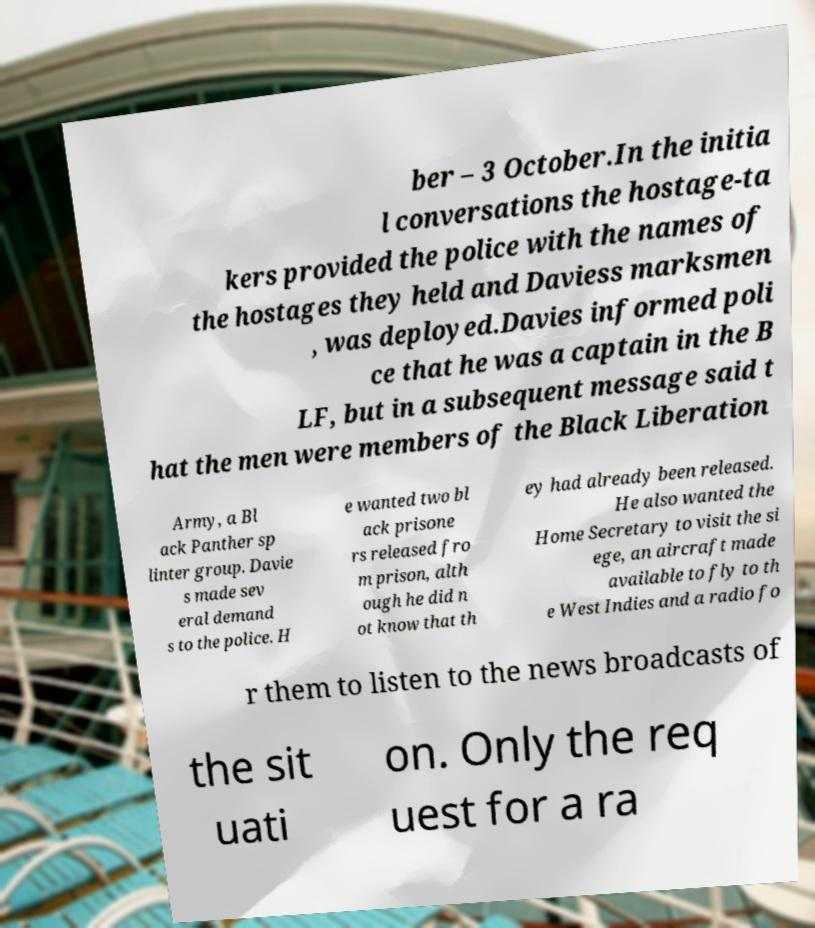Can you accurately transcribe the text from the provided image for me? ber – 3 October.In the initia l conversations the hostage-ta kers provided the police with the names of the hostages they held and Daviess marksmen , was deployed.Davies informed poli ce that he was a captain in the B LF, but in a subsequent message said t hat the men were members of the Black Liberation Army, a Bl ack Panther sp linter group. Davie s made sev eral demand s to the police. H e wanted two bl ack prisone rs released fro m prison, alth ough he did n ot know that th ey had already been released. He also wanted the Home Secretary to visit the si ege, an aircraft made available to fly to th e West Indies and a radio fo r them to listen to the news broadcasts of the sit uati on. Only the req uest for a ra 